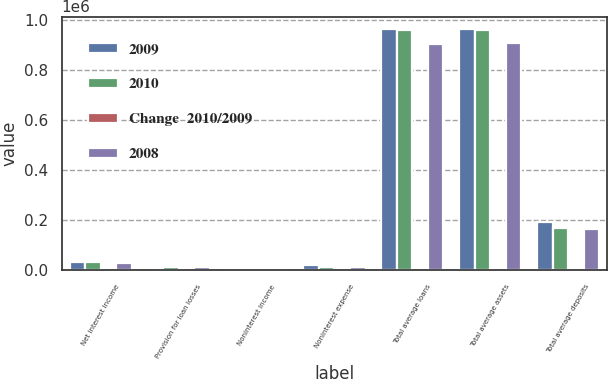<chart> <loc_0><loc_0><loc_500><loc_500><stacked_bar_chart><ecel><fcel>Net interest income<fcel>Provision for loan losses<fcel>Noninterest income<fcel>Noninterest expense<fcel>Total average loans<fcel>Total average assets<fcel>Total average deposits<nl><fcel>2009<fcel>33839<fcel>5126<fcel>1507<fcel>20345<fcel>965995<fcel>966900<fcel>193820<nl><fcel>2010<fcel>34689<fcel>13955<fcel>1356<fcel>14432<fcel>961364<fcel>962701<fcel>168286<nl><fcel>Change  2010/2009<fcel>2.5<fcel>63.3<fcel>11.1<fcel>41<fcel>0.5<fcel>0.4<fcel>15.2<nl><fcel>2008<fcel>29766<fcel>15441<fcel>1673<fcel>13831<fcel>905504<fcel>909234<fcel>164771<nl></chart> 